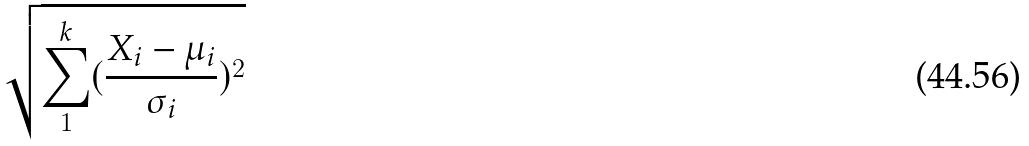<formula> <loc_0><loc_0><loc_500><loc_500>\sqrt { \sum _ { 1 } ^ { k } ( \frac { X _ { i } - \mu _ { i } } { \sigma _ { i } } ) ^ { 2 } }</formula> 